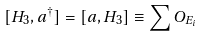Convert formula to latex. <formula><loc_0><loc_0><loc_500><loc_500>[ H _ { 3 } , a ^ { \dagger } ] = [ a , H _ { 3 } ] \equiv \sum O _ { E _ { i } }</formula> 